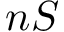Convert formula to latex. <formula><loc_0><loc_0><loc_500><loc_500>n S</formula> 